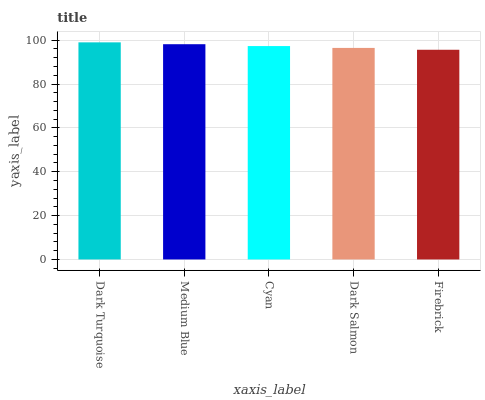Is Firebrick the minimum?
Answer yes or no. Yes. Is Dark Turquoise the maximum?
Answer yes or no. Yes. Is Medium Blue the minimum?
Answer yes or no. No. Is Medium Blue the maximum?
Answer yes or no. No. Is Dark Turquoise greater than Medium Blue?
Answer yes or no. Yes. Is Medium Blue less than Dark Turquoise?
Answer yes or no. Yes. Is Medium Blue greater than Dark Turquoise?
Answer yes or no. No. Is Dark Turquoise less than Medium Blue?
Answer yes or no. No. Is Cyan the high median?
Answer yes or no. Yes. Is Cyan the low median?
Answer yes or no. Yes. Is Medium Blue the high median?
Answer yes or no. No. Is Firebrick the low median?
Answer yes or no. No. 